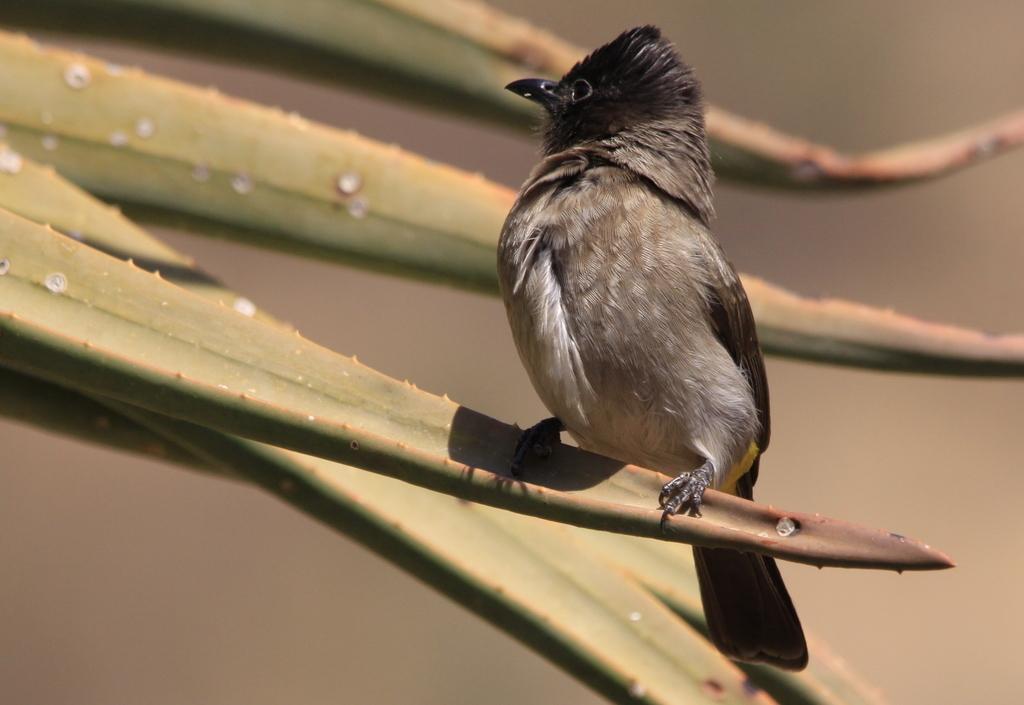Could you give a brief overview of what you see in this image? In this picture there is a bird standing on the plant and the background is blurry. 